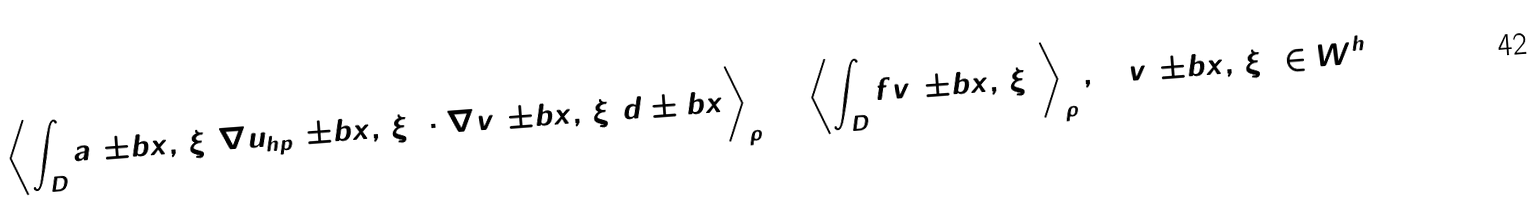<formula> <loc_0><loc_0><loc_500><loc_500>\left \langle \int _ { D } a ( \pm b { x } , \, { \xi } ) \nabla u _ { h p } ( \pm b { x } , \, { \xi } ) \cdot \nabla v ( \pm b { x } , \, { \xi } ) d \pm b { x } \right \rangle _ { \rho } = \left \langle \int _ { D } f v ( \pm b { x } , \, { \xi } ) \right \rangle _ { \rho } , \quad v ( \pm b { x } , \, { \xi } ) \in W ^ { h }</formula> 